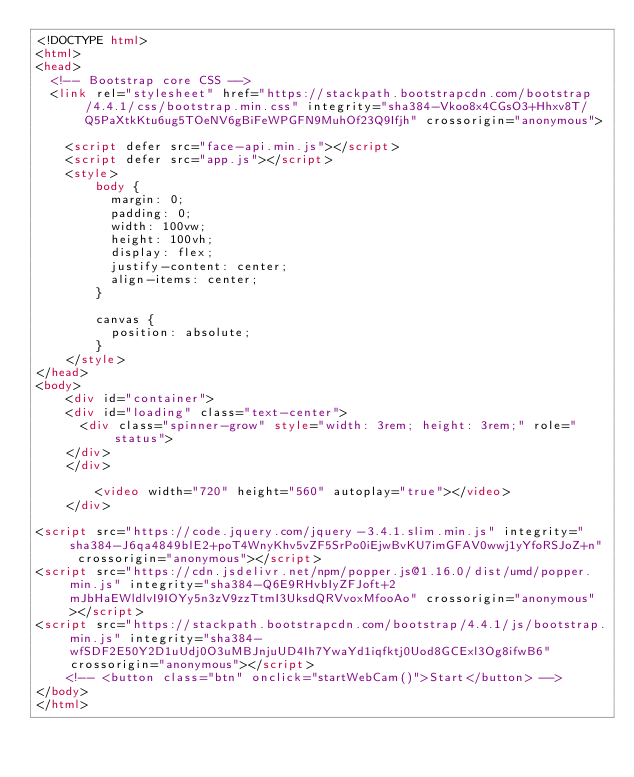Convert code to text. <code><loc_0><loc_0><loc_500><loc_500><_HTML_><!DOCTYPE html>
<html>
<head>
  <!-- Bootstrap core CSS -->
  <link rel="stylesheet" href="https://stackpath.bootstrapcdn.com/bootstrap/4.4.1/css/bootstrap.min.css" integrity="sha384-Vkoo8x4CGsO3+Hhxv8T/Q5PaXtkKtu6ug5TOeNV6gBiFeWPGFN9MuhOf23Q9Ifjh" crossorigin="anonymous">

    <script defer src="face-api.min.js"></script>
    <script defer src="app.js"></script>
    <style>
        body {
          margin: 0;
          padding: 0;
          width: 100vw;
          height: 100vh;
          display: flex;
          justify-content: center;
          align-items: center;
        }
    
        canvas {
          position: absolute;
        }
    </style>
</head>
<body>
	<div id="container">
    <div id="loading" class="text-center">
      <div class="spinner-grow" style="width: 3rem; height: 3rem;" role="status">
    </div>
    </div>
        
		<video width="720" height="560" autoplay="true"></video>
	</div>

<script src="https://code.jquery.com/jquery-3.4.1.slim.min.js" integrity="sha384-J6qa4849blE2+poT4WnyKhv5vZF5SrPo0iEjwBvKU7imGFAV0wwj1yYfoRSJoZ+n" crossorigin="anonymous"></script>
<script src="https://cdn.jsdelivr.net/npm/popper.js@1.16.0/dist/umd/popper.min.js" integrity="sha384-Q6E9RHvbIyZFJoft+2mJbHaEWldlvI9IOYy5n3zV9zzTtmI3UksdQRVvoxMfooAo" crossorigin="anonymous"></script>
<script src="https://stackpath.bootstrapcdn.com/bootstrap/4.4.1/js/bootstrap.min.js" integrity="sha384-wfSDF2E50Y2D1uUdj0O3uMBJnjuUD4Ih7YwaYd1iqfktj0Uod8GCExl3Og8ifwB6" crossorigin="anonymous"></script>
	<!-- <button class="btn" onclick="startWebCam()">Start</button> -->
</body>
</html></code> 